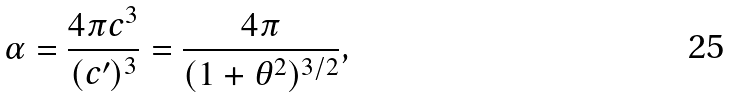<formula> <loc_0><loc_0><loc_500><loc_500>\alpha = \frac { 4 \pi c ^ { 3 } } { ( c ^ { \prime } ) ^ { 3 } } = \frac { 4 \pi } { ( 1 + \theta ^ { 2 } ) ^ { 3 / 2 } } ,</formula> 